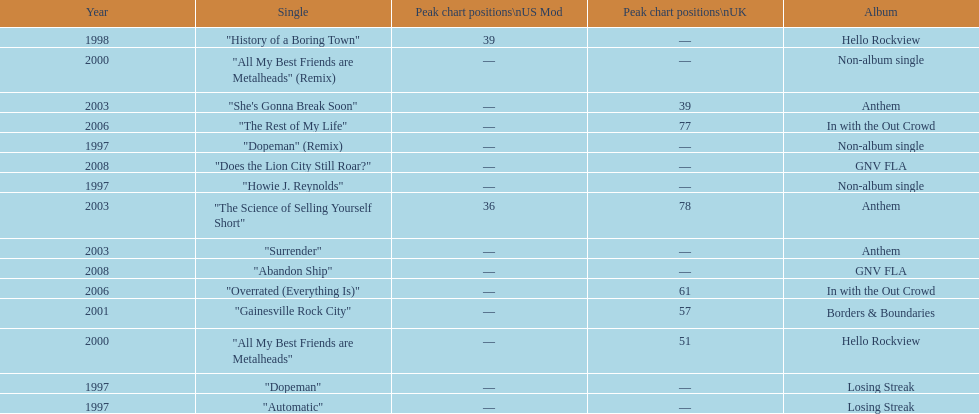What was the first single to earn a chart position? "History of a Boring Town". 